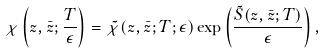Convert formula to latex. <formula><loc_0><loc_0><loc_500><loc_500>\chi \left ( z , \bar { z } ; \frac { T } { \epsilon } \right ) = \tilde { \chi } ( z , \bar { z } ; T ; \epsilon ) \exp \left ( \frac { \tilde { S } ( z , \bar { z } ; T ) } { \epsilon } \right ) ,</formula> 